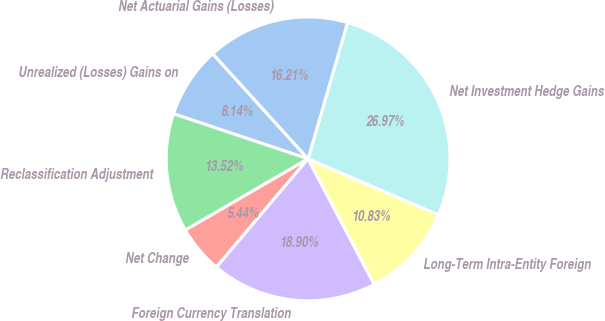Convert chart. <chart><loc_0><loc_0><loc_500><loc_500><pie_chart><fcel>Unrealized (Losses) Gains on<fcel>Reclassification Adjustment<fcel>Net Change<fcel>Foreign Currency Translation<fcel>Long-Term Intra-Entity Foreign<fcel>Net Investment Hedge Gains<fcel>Net Actuarial Gains (Losses)<nl><fcel>8.14%<fcel>13.52%<fcel>5.44%<fcel>18.9%<fcel>10.83%<fcel>26.97%<fcel>16.21%<nl></chart> 